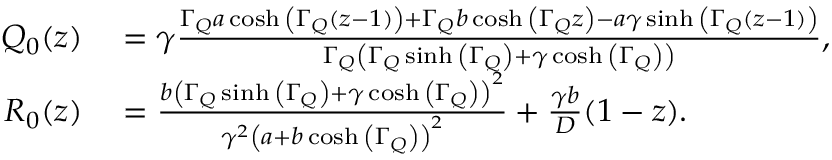<formula> <loc_0><loc_0><loc_500><loc_500>\begin{array} { r l } { Q _ { 0 } ( z ) } & = \gamma \frac { \Gamma _ { Q } a \cosh { \left ( \Gamma _ { Q } \left ( z - 1 \right ) \right ) } + \Gamma _ { Q } b \cosh { \left ( \Gamma _ { Q } z \right ) } - a \gamma \sinh { \left ( \Gamma _ { Q } \left ( z - 1 \right ) \right ) } } { \Gamma _ { Q } \left ( \Gamma _ { Q } \sinh { \left ( \Gamma _ { Q } \right ) } + \gamma \cosh { \left ( \Gamma _ { Q } \right ) } \right ) } , } \\ { R _ { 0 } ( z ) } & = \frac { b \left ( \Gamma _ { Q } \sinh { \left ( \Gamma _ { Q } \right ) } + \gamma \cosh { \left ( \Gamma _ { Q } \right ) } \right ) ^ { 2 } } { \gamma ^ { 2 } \left ( a + b \cosh { \left ( \Gamma _ { Q } \right ) } \right ) ^ { 2 } } + \frac { \gamma b } { D } ( 1 - z ) . } \end{array}</formula> 